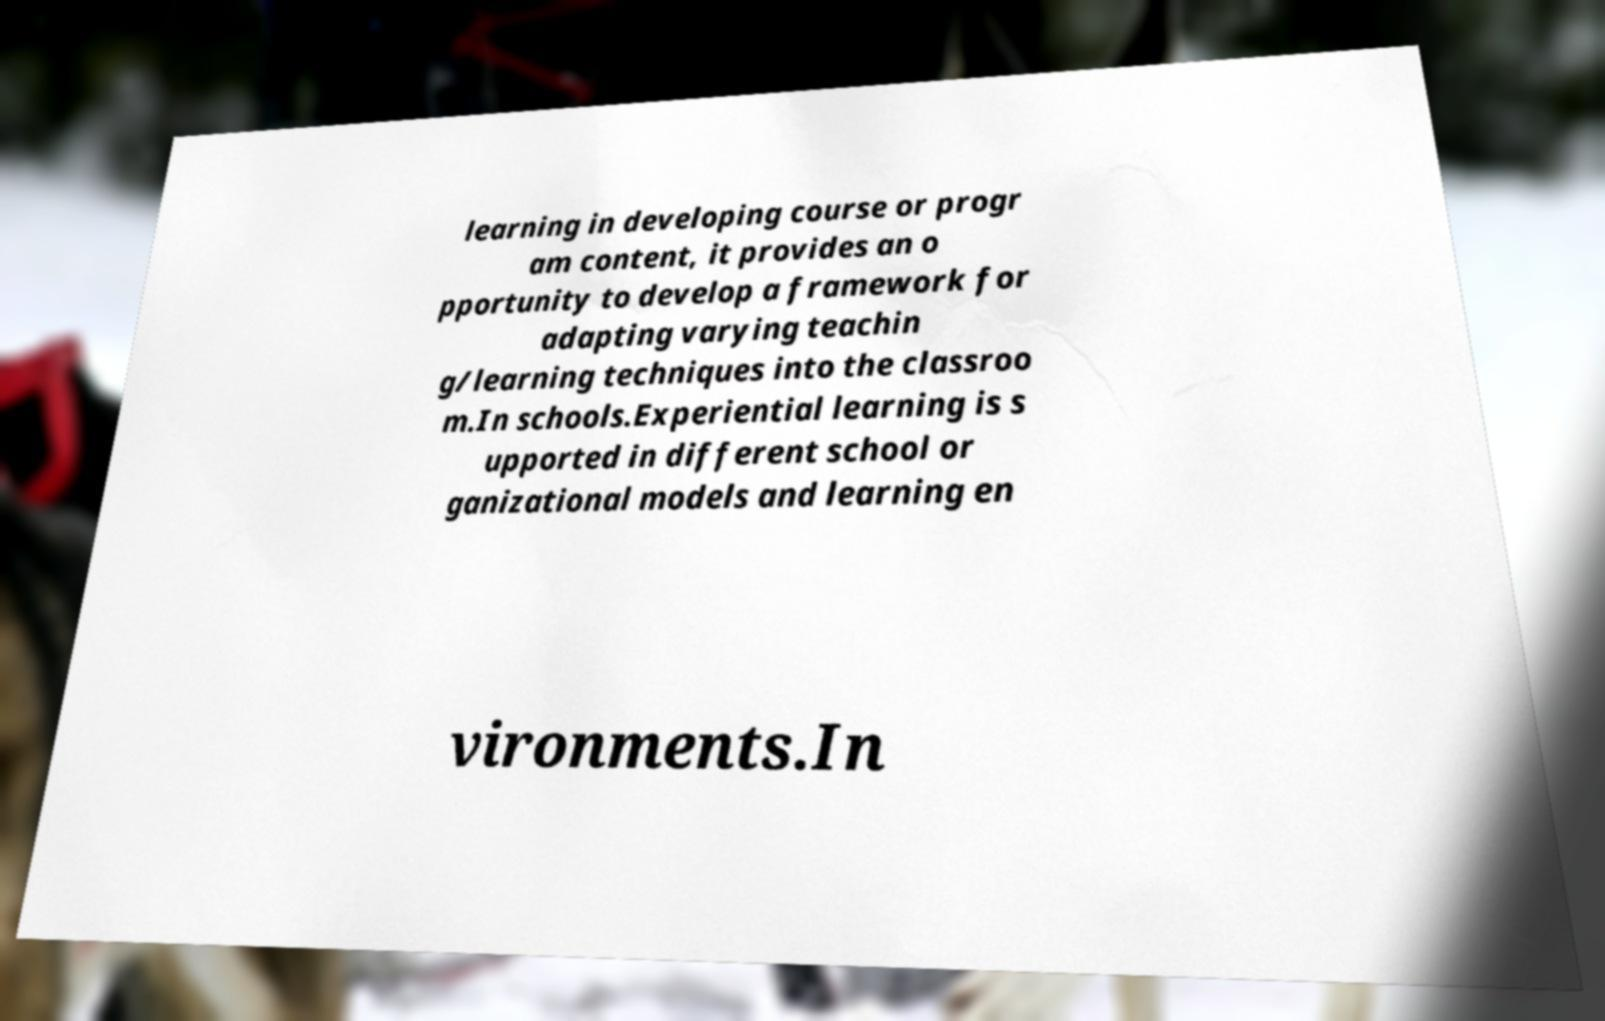I need the written content from this picture converted into text. Can you do that? learning in developing course or progr am content, it provides an o pportunity to develop a framework for adapting varying teachin g/learning techniques into the classroo m.In schools.Experiential learning is s upported in different school or ganizational models and learning en vironments.In 